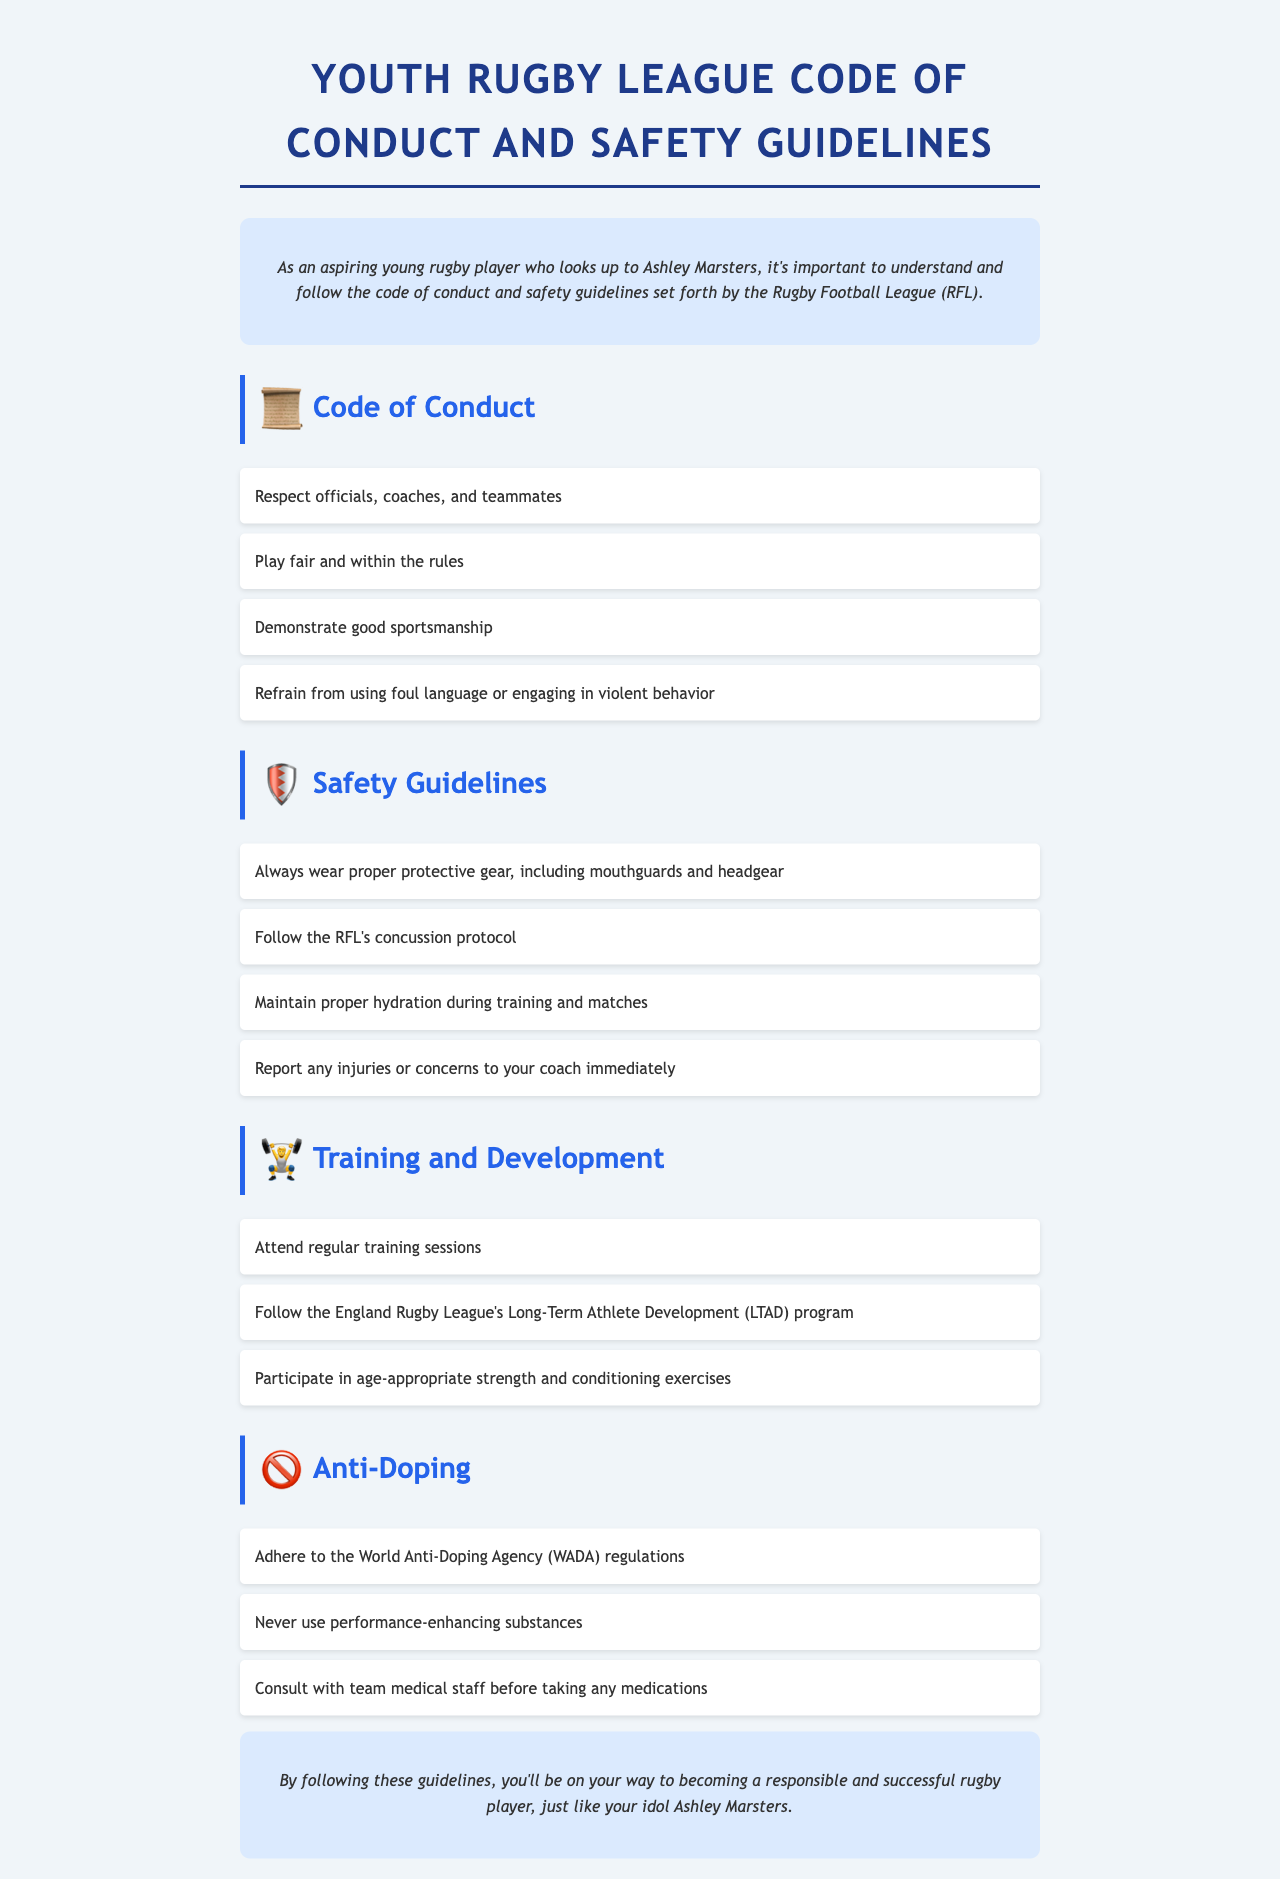What is the title of the document? The title of the document is specified at the top as it holds the main focus of the content.
Answer: Youth Rugby League Code of Conduct and Safety Guidelines How many sections are in the document? The document has four main sections that cover different areas related to youth rugby league.
Answer: Four What should a player do if they experience an injury? The guidelines state the importance of reporting injuries or concerns to ensure safety during play.
Answer: Report to the coach What is one requirement for wearing protective gear? The document lists mouthguards and headgear as essential components of proper protective gear that should be worn.
Answer: Mouthguards Which substance usage is prohibited according to the guidelines? The guidelines specify that using performance-enhancing substances is not allowed in the sport.
Answer: Performance-enhancing substances What kind of training program should players follow? The document mentions the importance of adhering to a specific training program aimed at the long-term development of athletes.
Answer: LTAD program What type of language should players refrain from using? The document highlights the need to maintain decorum in the game, including avoiding foul language.
Answer: Foul language How often should players attend training sessions? The document encourages consistent practice, indicating the necessity of regular attendance at training sessions.
Answer: Regularly 